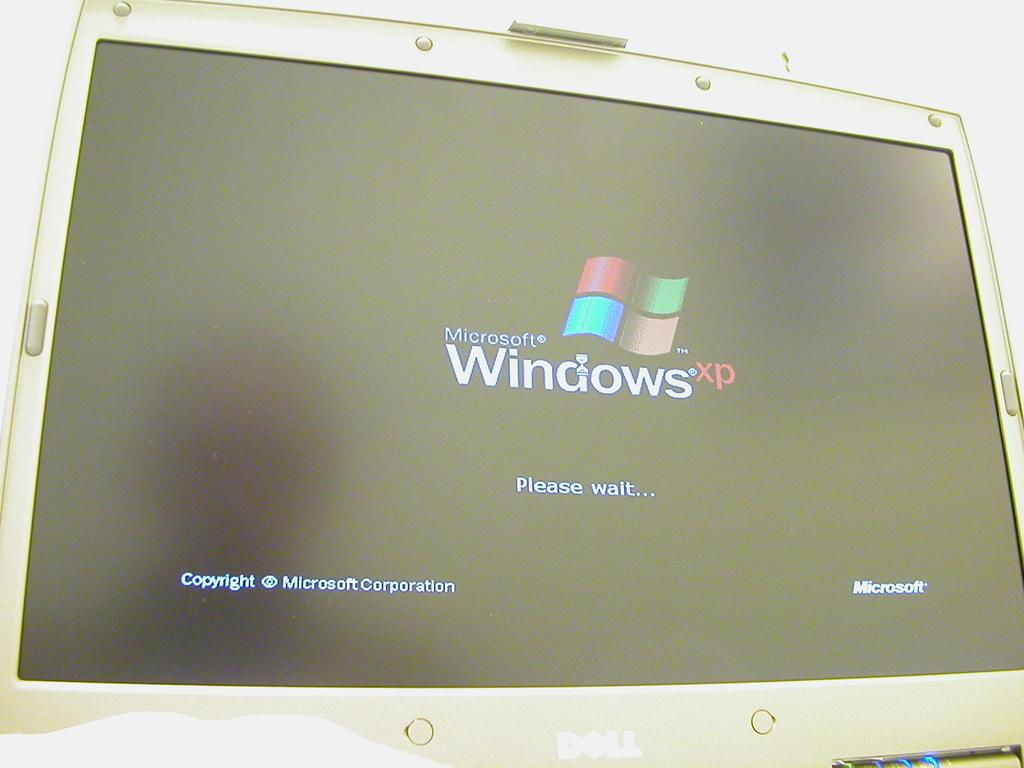<image>
Share a concise interpretation of the image provided. Computer monitor showing Microsoft Windows XP and telling the user to wait. 